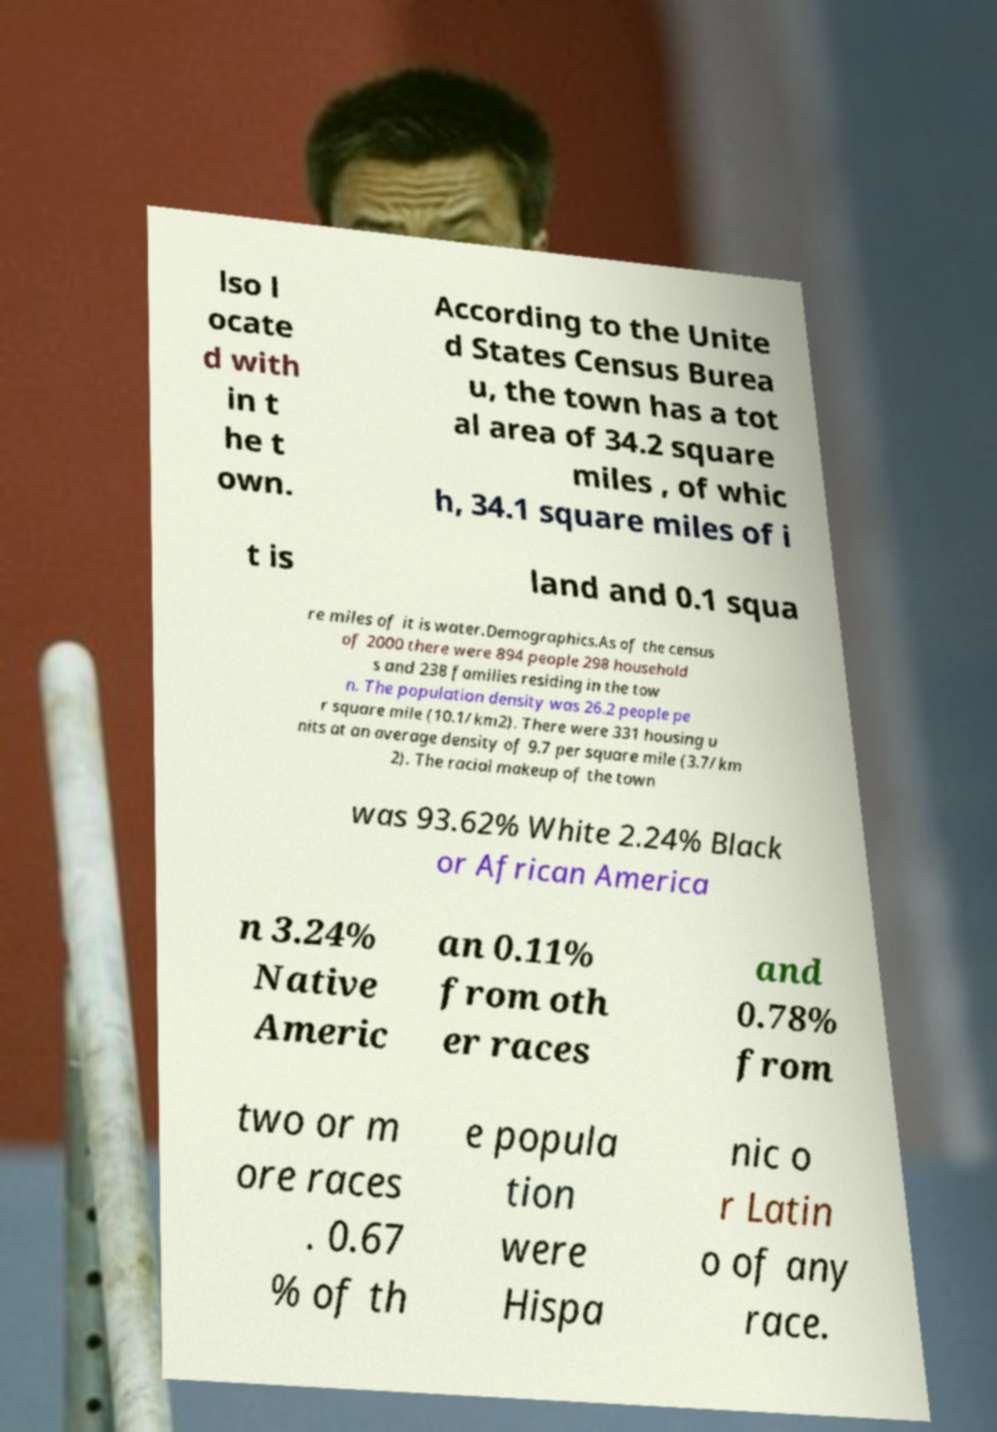Could you extract and type out the text from this image? lso l ocate d with in t he t own. According to the Unite d States Census Burea u, the town has a tot al area of 34.2 square miles , of whic h, 34.1 square miles of i t is land and 0.1 squa re miles of it is water.Demographics.As of the census of 2000 there were 894 people 298 household s and 238 families residing in the tow n. The population density was 26.2 people pe r square mile (10.1/km2). There were 331 housing u nits at an average density of 9.7 per square mile (3.7/km 2). The racial makeup of the town was 93.62% White 2.24% Black or African America n 3.24% Native Americ an 0.11% from oth er races and 0.78% from two or m ore races . 0.67 % of th e popula tion were Hispa nic o r Latin o of any race. 